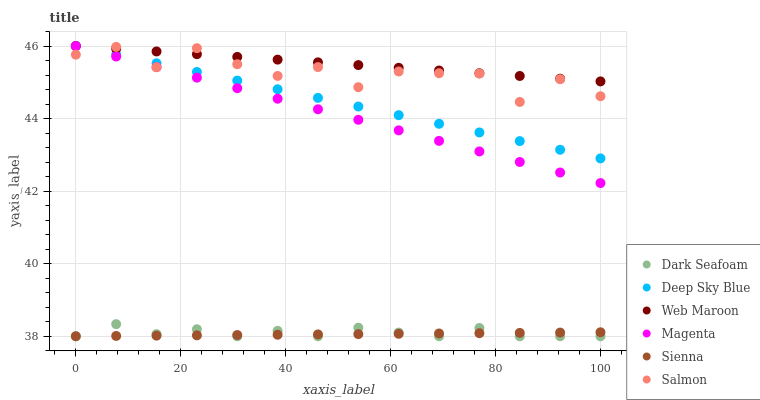Does Sienna have the minimum area under the curve?
Answer yes or no. Yes. Does Web Maroon have the maximum area under the curve?
Answer yes or no. Yes. Does Salmon have the minimum area under the curve?
Answer yes or no. No. Does Salmon have the maximum area under the curve?
Answer yes or no. No. Is Sienna the smoothest?
Answer yes or no. Yes. Is Salmon the roughest?
Answer yes or no. Yes. Is Salmon the smoothest?
Answer yes or no. No. Is Sienna the roughest?
Answer yes or no. No. Does Sienna have the lowest value?
Answer yes or no. Yes. Does Salmon have the lowest value?
Answer yes or no. No. Does Magenta have the highest value?
Answer yes or no. Yes. Does Salmon have the highest value?
Answer yes or no. No. Is Dark Seafoam less than Deep Sky Blue?
Answer yes or no. Yes. Is Deep Sky Blue greater than Dark Seafoam?
Answer yes or no. Yes. Does Web Maroon intersect Salmon?
Answer yes or no. Yes. Is Web Maroon less than Salmon?
Answer yes or no. No. Is Web Maroon greater than Salmon?
Answer yes or no. No. Does Dark Seafoam intersect Deep Sky Blue?
Answer yes or no. No. 